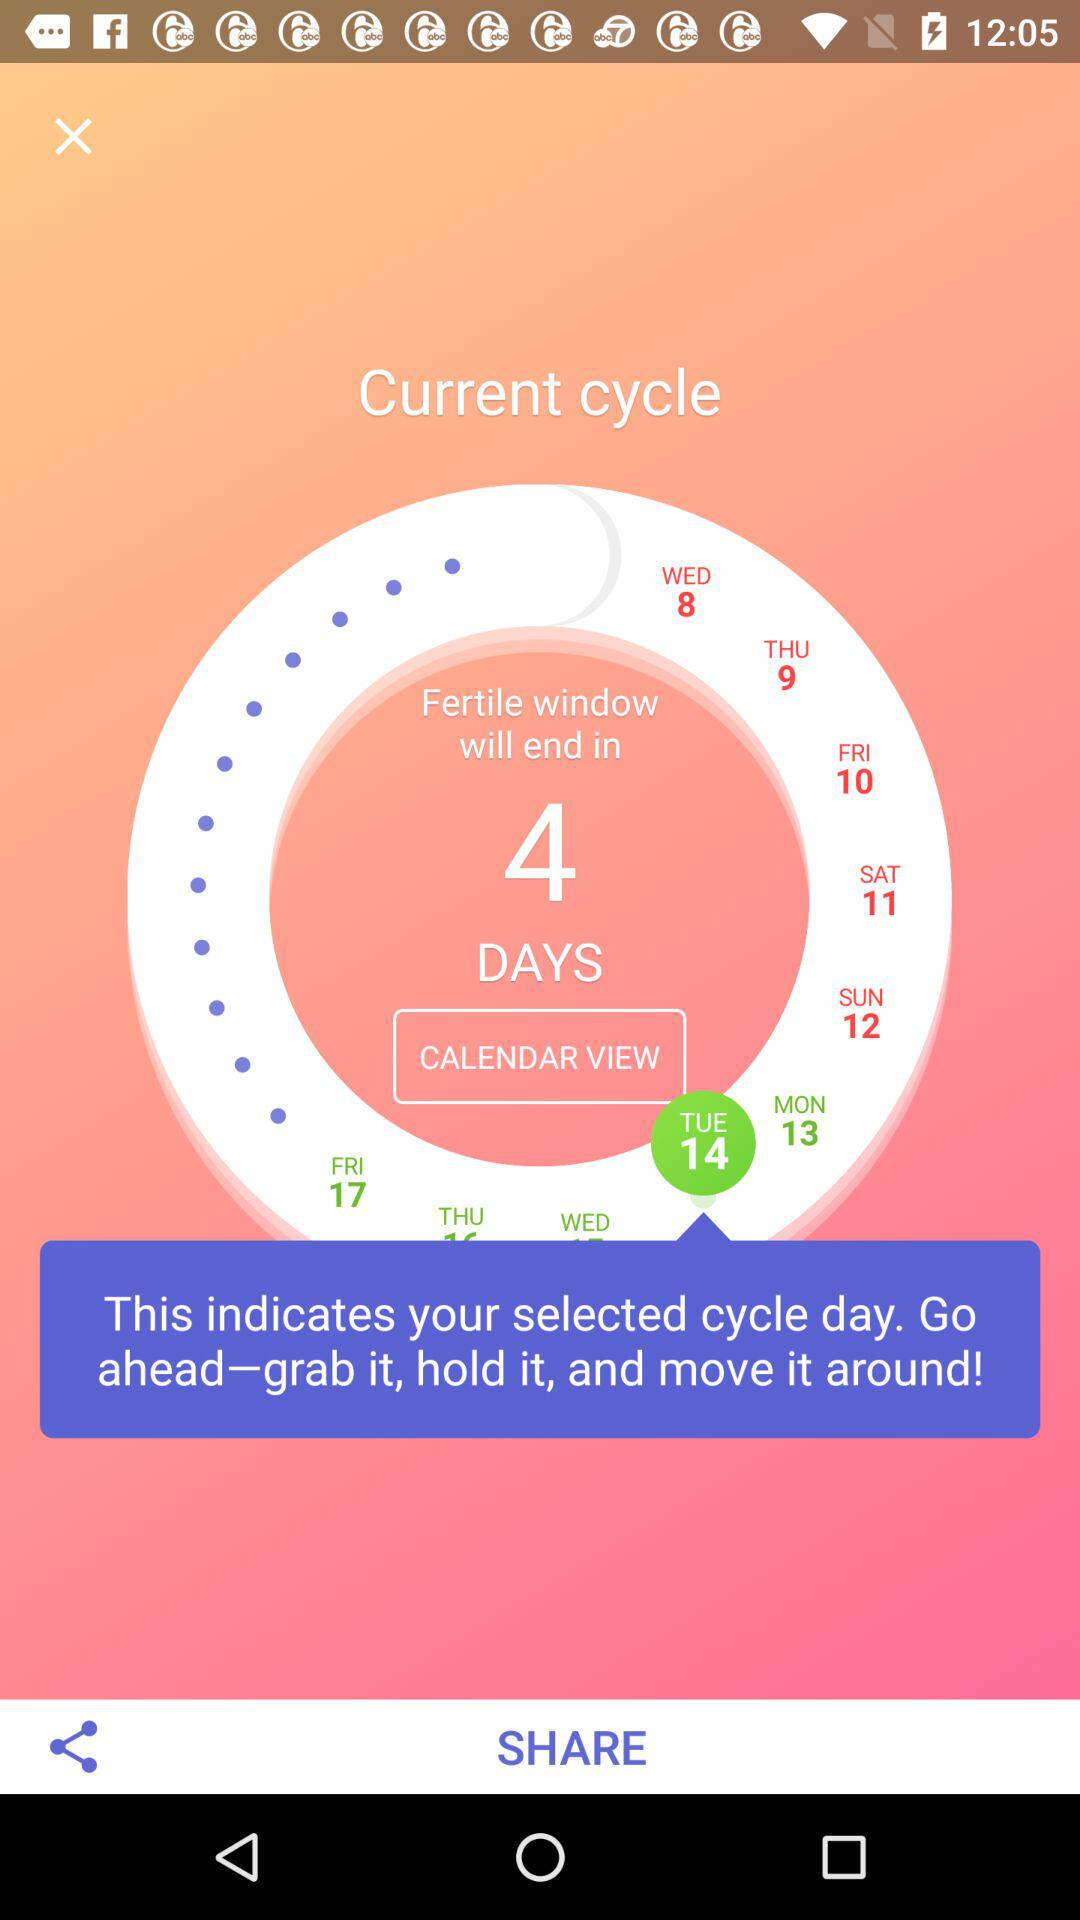When will the fertile window end? The fertile window will end in 4 days. 